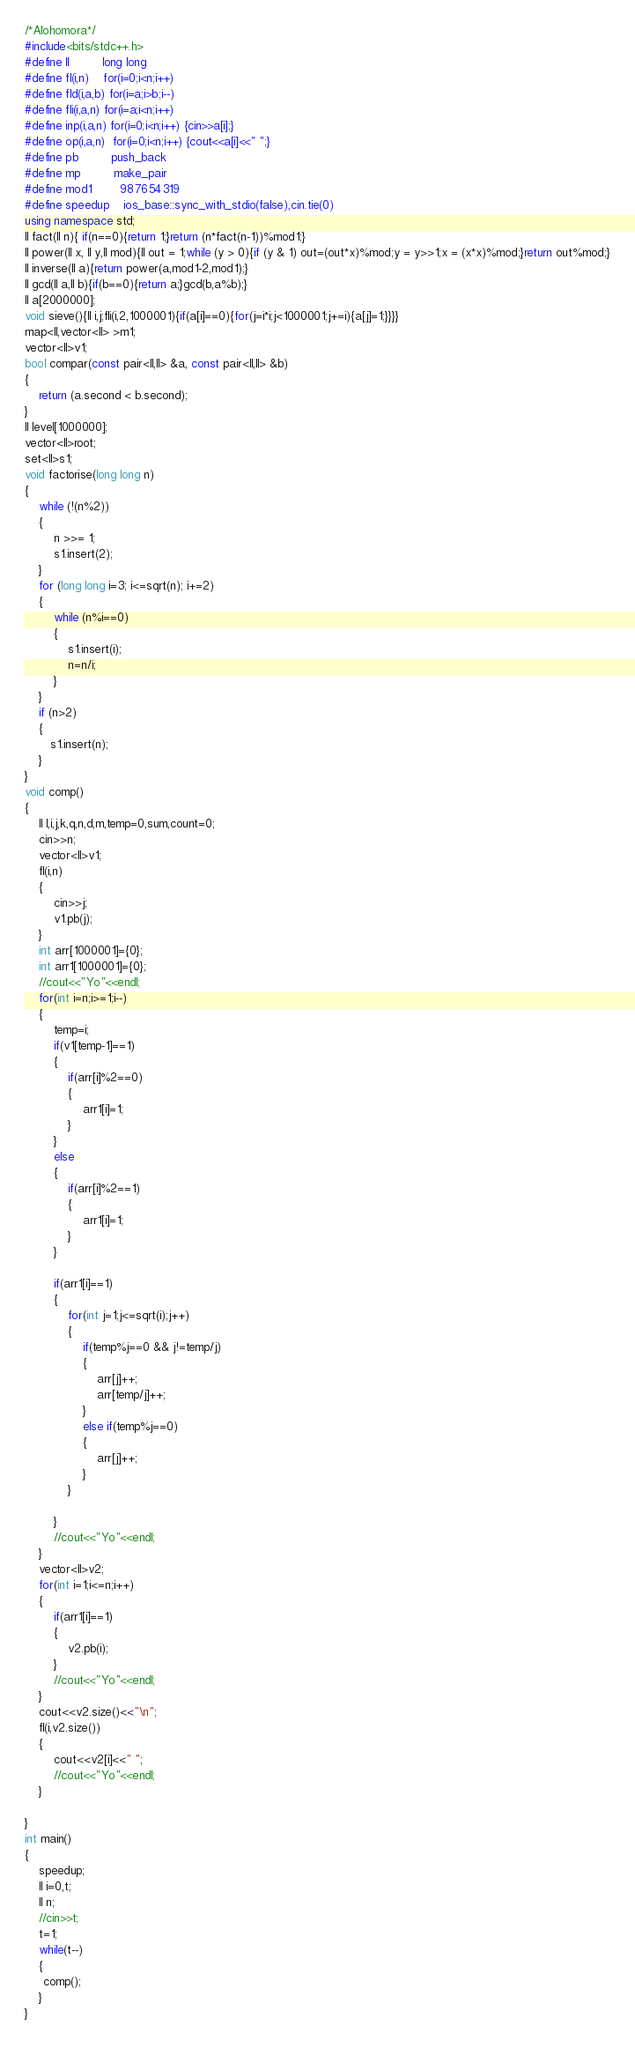<code> <loc_0><loc_0><loc_500><loc_500><_C++_>/*Alohomora*/
#include<bits/stdc++.h>
#define ll         long long
#define fl(i,n)    for(i=0;i<n;i++)
#define fld(i,a,b) for(i=a;i>b;i--)
#define fli(i,a,n) for(i=a;i<n;i++)
#define inp(i,a,n) for(i=0;i<n;i++) {cin>>a[i];}
#define op(i,a,n)  for(i=0;i<n;i++) {cout<<a[i]<<" ";}
#define pb         push_back
#define mp         make_pair
#define mod1        987654319 
#define speedup    ios_base::sync_with_stdio(false),cin.tie(0)
using namespace std;
ll fact(ll n){ if(n==0){return 1;}return (n*fact(n-1))%mod1;}
ll power(ll x, ll y,ll mod){ll out = 1;while (y > 0){if (y & 1) out=(out*x)%mod;y = y>>1;x = (x*x)%mod;}return out%mod;}
ll inverse(ll a){return power(a,mod1-2,mod1);}
ll gcd(ll a,ll b){if(b==0){return a;}gcd(b,a%b);}
ll a[2000000];
void sieve(){ll i,j;fli(i,2,1000001){if(a[i]==0){for(j=i*i;j<1000001;j+=i){a[j]=1;}}}}
map<ll,vector<ll> >m1;
vector<ll>v1;
bool compar(const pair<ll,ll> &a, const pair<ll,ll> &b) 
{ 
    return (a.second < b.second);
} 
ll level[1000000];
vector<ll>root;
set<ll>s1;
void factorise(long long n) 
{ 
    while (!(n%2)) 
    { 
        n >>= 1; 
        s1.insert(2);
    } 
    for (long long i=3; i<=sqrt(n); i+=2) 
    { 
        while (n%i==0) 
        { 
        	s1.insert(i);
            n=n/i; 
        } 
    } 
  	if (n>2) 
  	{
       s1.insert(n);
	}
} 
void comp()
{
	ll l,i,j,k,q,n,d,m,temp=0,sum,count=0;
	cin>>n;
	vector<ll>v1;
	fl(i,n)
	{
		cin>>j;
		v1.pb(j);
	}
	int arr[1000001]={0};
	int arr1[1000001]={0};
	//cout<<"Yo"<<endl;
	for(int i=n;i>=1;i--)
	{
		temp=i;
		if(v1[temp-1]==1)
		{
			if(arr[i]%2==0)
			{
				arr1[i]=1;
			}
		}
		else
		{
			if(arr[i]%2==1)
			{
				arr1[i]=1;
			}
		}	
		
		if(arr1[i]==1)
		{
			for(int j=1;j<=sqrt(i);j++)
			{
				if(temp%j==0 && j!=temp/j)
				{
					arr[j]++;
					arr[temp/j]++;
				}
				else if(temp%j==0)
				{
					arr[j]++;
				}
			}

		}
		//cout<<"Yo"<<endl;
	}
	vector<ll>v2;
	for(int i=1;i<=n;i++)
	{
		if(arr1[i]==1)
		{
			v2.pb(i);
		}
		//cout<<"Yo"<<endl;
	}
	cout<<v2.size()<<"\n";
	fl(i,v2.size())
	{
		cout<<v2[i]<<" ";
		//cout<<"Yo"<<endl;
	}
	
} 
int main()
{
	speedup;
	ll i=0,t;
	ll n;
	//cin>>t;
	t=1;
	while(t--)
	{
	 comp();
	}
}</code> 